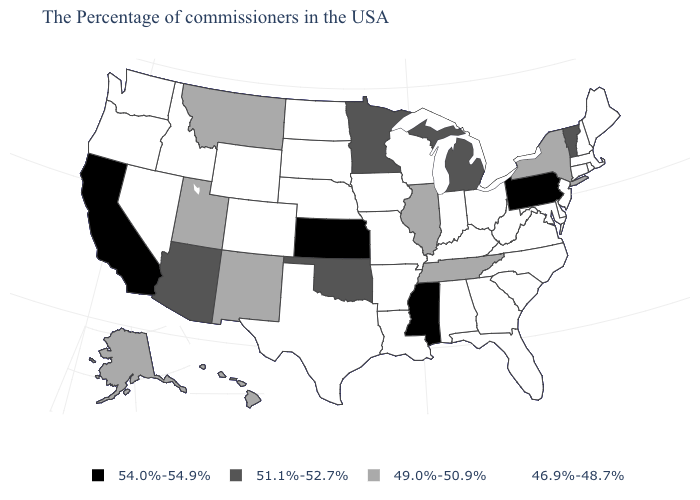Name the states that have a value in the range 46.9%-48.7%?
Answer briefly. Maine, Massachusetts, Rhode Island, New Hampshire, Connecticut, New Jersey, Delaware, Maryland, Virginia, North Carolina, South Carolina, West Virginia, Ohio, Florida, Georgia, Kentucky, Indiana, Alabama, Wisconsin, Louisiana, Missouri, Arkansas, Iowa, Nebraska, Texas, South Dakota, North Dakota, Wyoming, Colorado, Idaho, Nevada, Washington, Oregon. Name the states that have a value in the range 54.0%-54.9%?
Quick response, please. Pennsylvania, Mississippi, Kansas, California. Does Rhode Island have the same value as Nebraska?
Quick response, please. Yes. Among the states that border Connecticut , which have the highest value?
Give a very brief answer. New York. Name the states that have a value in the range 54.0%-54.9%?
Concise answer only. Pennsylvania, Mississippi, Kansas, California. What is the lowest value in the USA?
Write a very short answer. 46.9%-48.7%. What is the value of Pennsylvania?
Write a very short answer. 54.0%-54.9%. Name the states that have a value in the range 54.0%-54.9%?
Short answer required. Pennsylvania, Mississippi, Kansas, California. Which states hav the highest value in the West?
Answer briefly. California. Name the states that have a value in the range 46.9%-48.7%?
Concise answer only. Maine, Massachusetts, Rhode Island, New Hampshire, Connecticut, New Jersey, Delaware, Maryland, Virginia, North Carolina, South Carolina, West Virginia, Ohio, Florida, Georgia, Kentucky, Indiana, Alabama, Wisconsin, Louisiana, Missouri, Arkansas, Iowa, Nebraska, Texas, South Dakota, North Dakota, Wyoming, Colorado, Idaho, Nevada, Washington, Oregon. Does Mississippi have the highest value in the South?
Answer briefly. Yes. Does Ohio have a lower value than Michigan?
Give a very brief answer. Yes. What is the value of Tennessee?
Be succinct. 49.0%-50.9%. Does Alabama have the lowest value in the USA?
Quick response, please. Yes. Which states hav the highest value in the Northeast?
Quick response, please. Pennsylvania. 